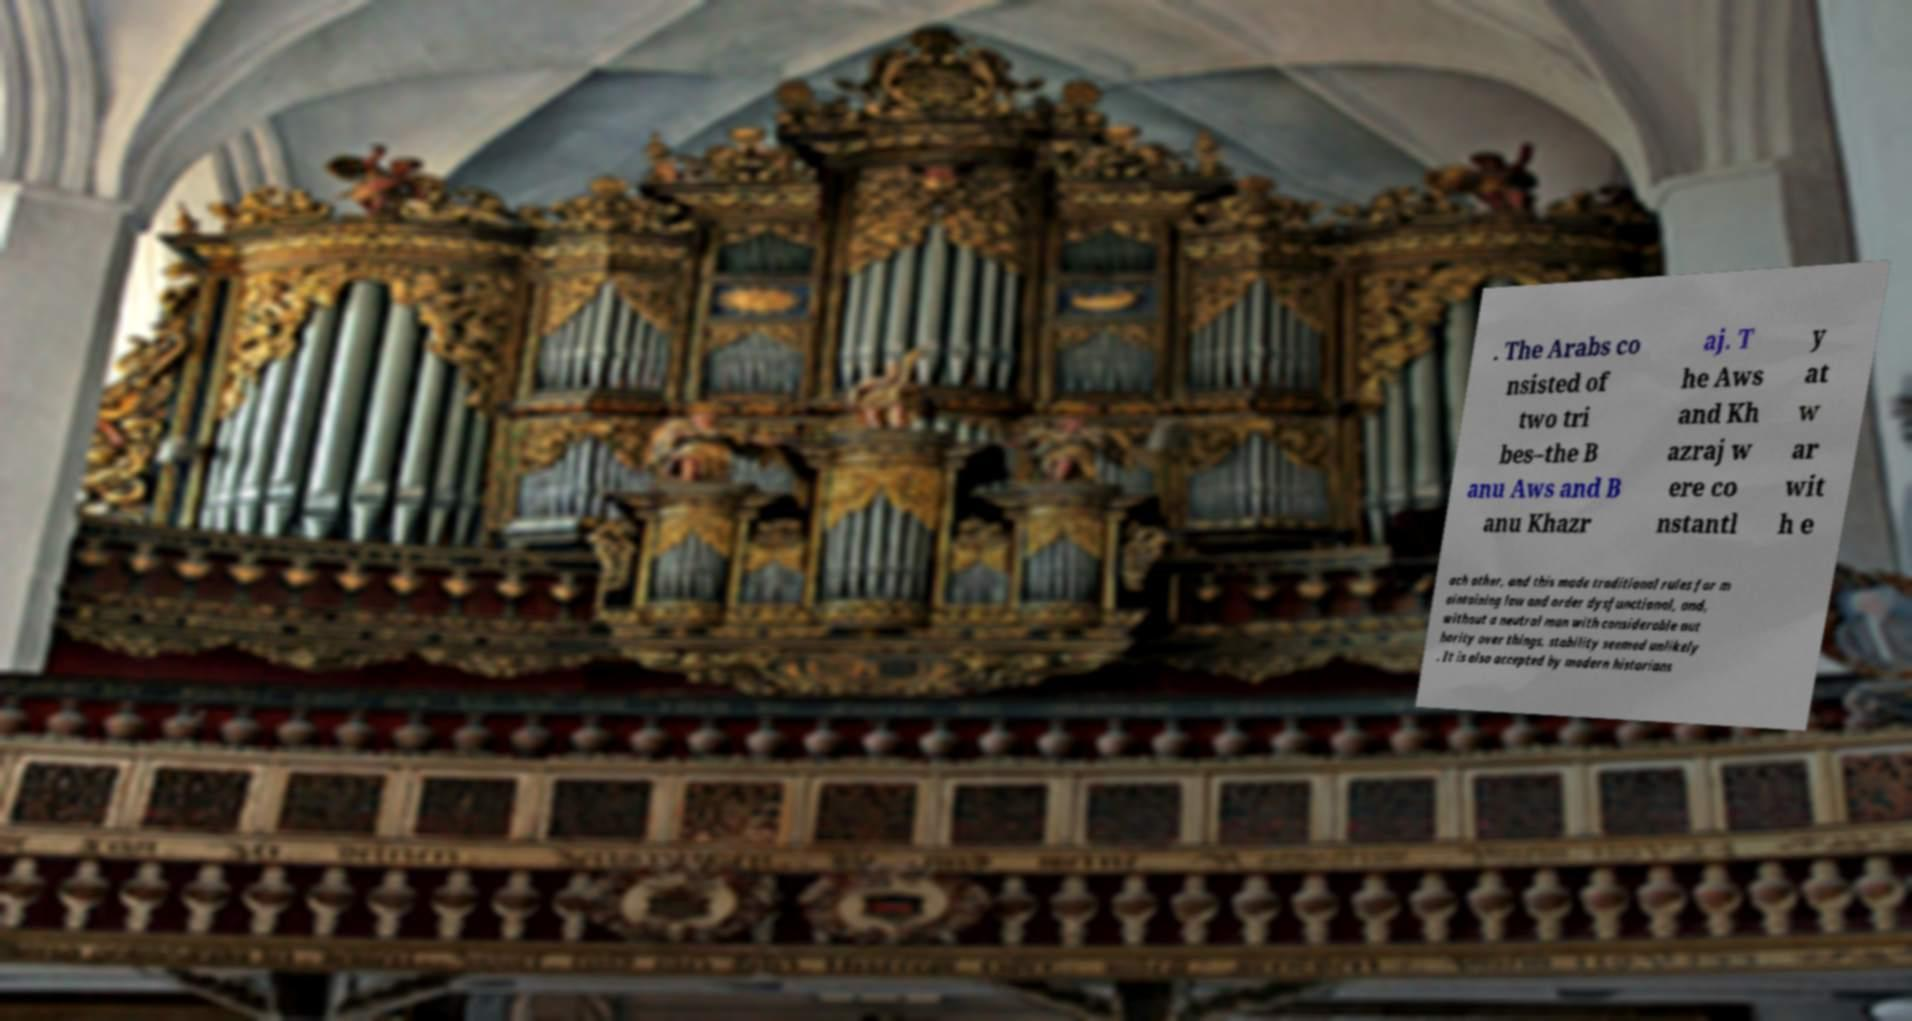Could you assist in decoding the text presented in this image and type it out clearly? . The Arabs co nsisted of two tri bes–the B anu Aws and B anu Khazr aj. T he Aws and Kh azraj w ere co nstantl y at w ar wit h e ach other, and this made traditional rules for m aintaining law and order dysfunctional, and, without a neutral man with considerable aut hority over things, stability seemed unlikely . It is also accepted by modern historians 